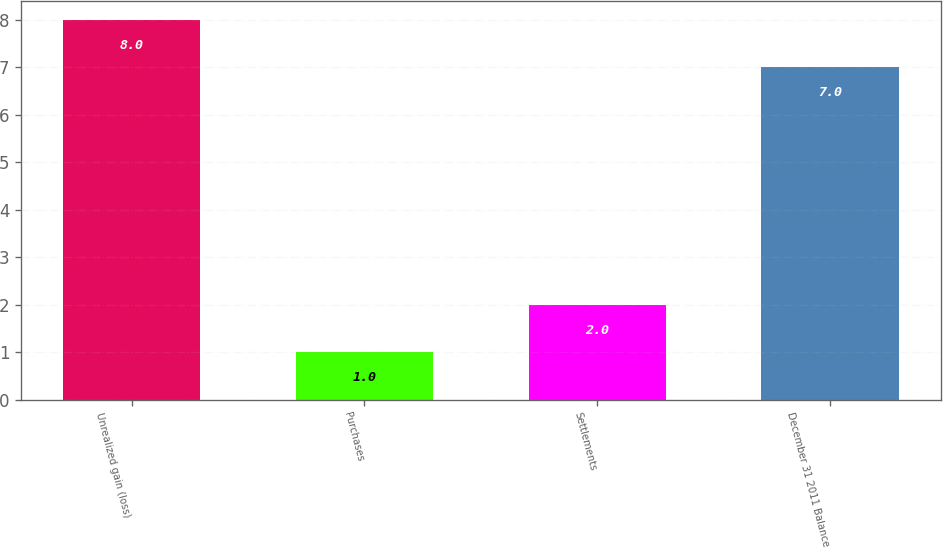Convert chart. <chart><loc_0><loc_0><loc_500><loc_500><bar_chart><fcel>Unrealized gain (loss)<fcel>Purchases<fcel>Settlements<fcel>December 31 2011 Balance<nl><fcel>8<fcel>1<fcel>2<fcel>7<nl></chart> 